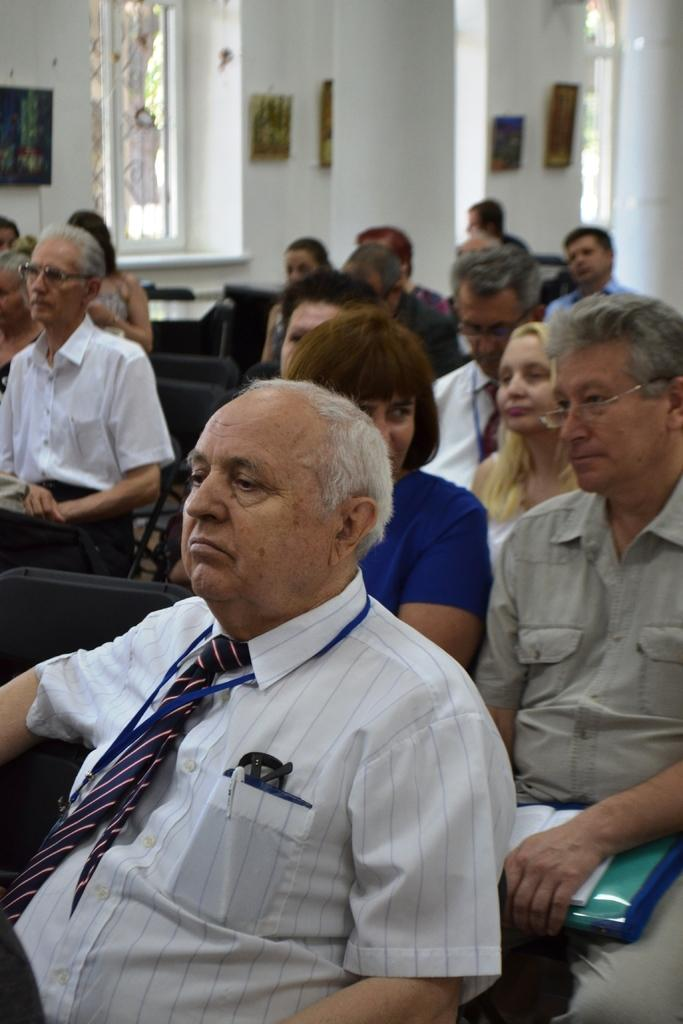What type of people are sitting on chairs in the image? There are old men sitting on chairs in the image. Where does the image appear to be taken? The image appears to be taken inside a church. What can be seen on the wall in the background of the image? There is a window on the wall in the background of the image. What is located on either side of the window? There are photo frames on either side of the window. What type of shirt is the nation wearing in the image? There is no nation or shirt present in the image; it features old men sitting on chairs inside a church. 